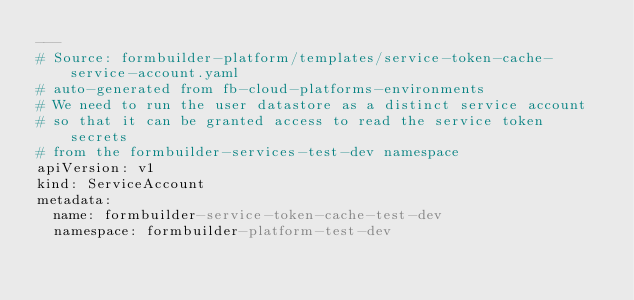Convert code to text. <code><loc_0><loc_0><loc_500><loc_500><_YAML_>---
# Source: formbuilder-platform/templates/service-token-cache-service-account.yaml
# auto-generated from fb-cloud-platforms-environments
# We need to run the user datastore as a distinct service account
# so that it can be granted access to read the service token secrets
# from the formbuilder-services-test-dev namespace
apiVersion: v1
kind: ServiceAccount
metadata:
  name: formbuilder-service-token-cache-test-dev
  namespace: formbuilder-platform-test-dev
</code> 